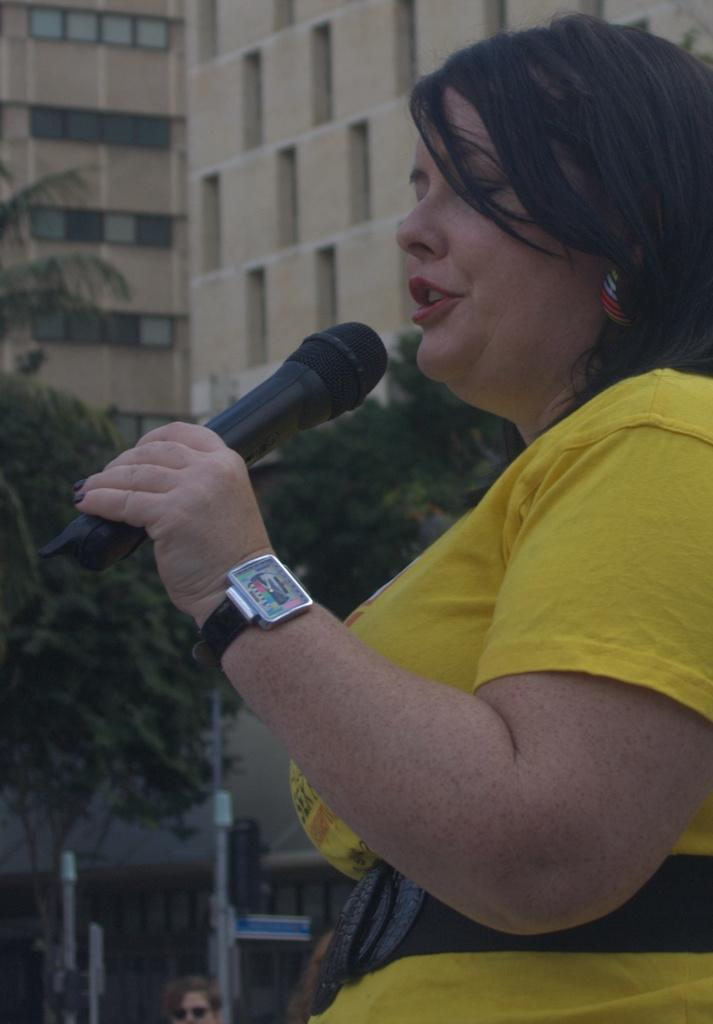Who is the main subject in the image? There is a lady in the image. What is the lady wearing? The lady is wearing a yellow dress. What accessory is the lady wearing? The lady is wearing a watch. What is the lady holding in the image? The lady is holding a microphone. What is the lady doing in the image? The lady is talking. What can be seen in the background of the image? There is a building and a tree in the background of the image. What type of hammer can be seen in the lady's hand in the image? There is no hammer present in the image; the lady is holding a microphone. What street is the lady standing on in the image? The image does not show a street; it only shows the lady, the microphone, and the background elements. 